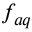Convert formula to latex. <formula><loc_0><loc_0><loc_500><loc_500>f _ { a q }</formula> 